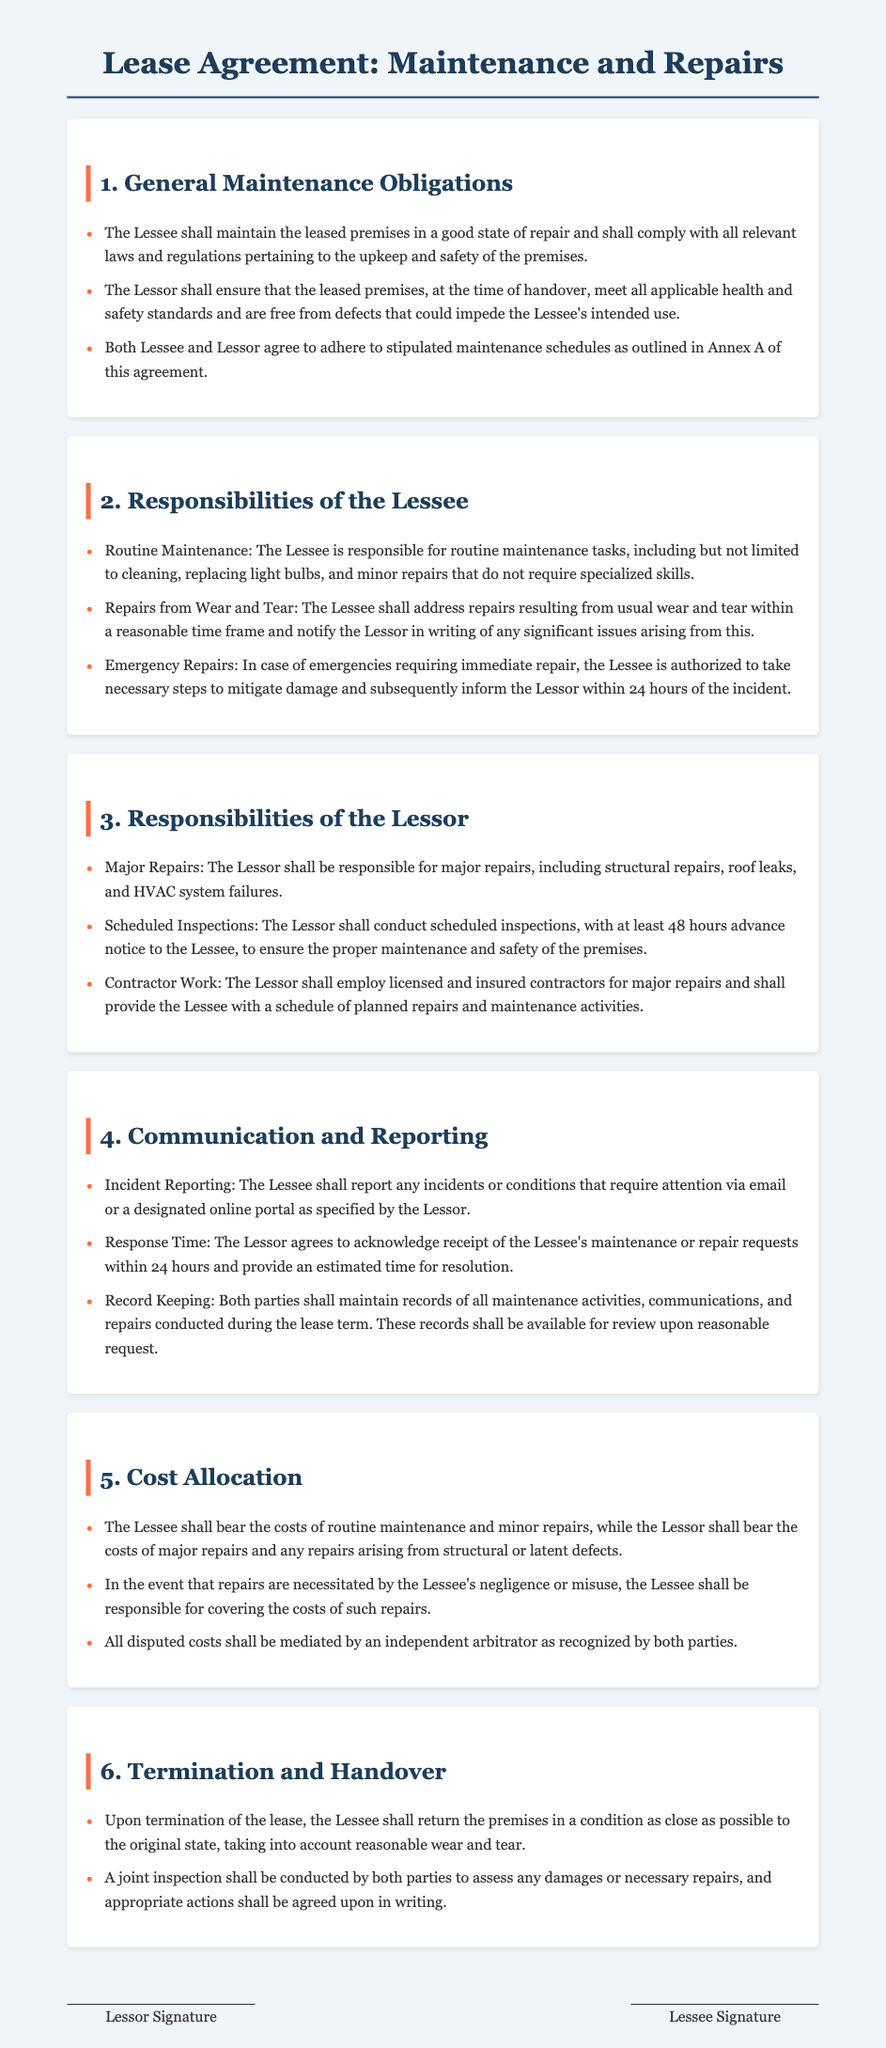What are the Lessee's routine maintenance responsibilities? The Lessee is responsible for routine maintenance tasks, including but not limited to cleaning, replacing light bulbs, and minor repairs that do not require specialized skills.
Answer: routine maintenance tasks What is the Lessor responsible for? The Lessor is responsible for major repairs, including structural repairs, roof leaks, and HVAC system failures.
Answer: major repairs What is the time frame for the Lessee to notify the Lessor of significant issues? The Lessee shall notify the Lessor in writing of any significant issues arising from repairs within a reasonable time frame.
Answer: reasonable time frame How long does the Lessor have to acknowledge receipt of maintenance requests? The Lessor agrees to acknowledge receipt of the Lessee's maintenance or repair requests within 24 hours.
Answer: 24 hours What are the Lessee's responsibilities in case of emergencies? In case of emergencies requiring immediate repair, the Lessee is authorized to take necessary steps to mitigate damage and subsequently inform the Lessor within 24 hours of the incident.
Answer: inform the Lessor within 24 hours What costs does the Lessee bear? The Lessee shall bear the costs of routine maintenance and minor repairs.
Answer: routine maintenance and minor repairs What must happen upon termination of the lease? Upon termination of the lease, the Lessee shall return the premises in a condition as close as possible to the original state, taking into account reasonable wear and tear.
Answer: return the premises in a condition as close as possible to the original state What is required for schedule inspections by the Lessor? The Lessor shall conduct scheduled inspections, with at least 48 hours advance notice to the Lessee.
Answer: 48 hours advance notice 